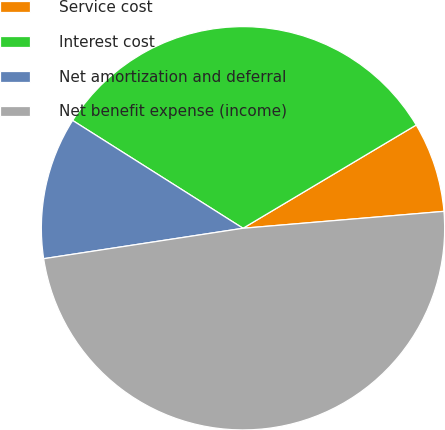Convert chart to OTSL. <chart><loc_0><loc_0><loc_500><loc_500><pie_chart><fcel>Service cost<fcel>Interest cost<fcel>Net amortization and deferral<fcel>Net benefit expense (income)<nl><fcel>7.22%<fcel>32.46%<fcel>11.39%<fcel>48.92%<nl></chart> 